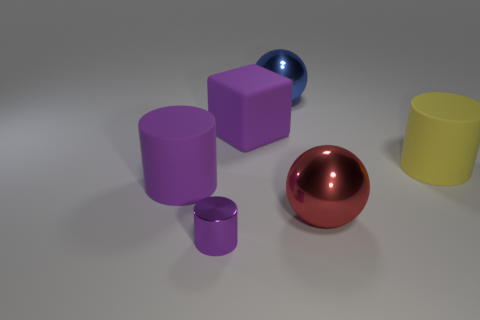Subtract all matte cylinders. How many cylinders are left? 1 Add 3 purple metallic cylinders. How many objects exist? 9 Subtract all balls. How many objects are left? 4 Add 2 tiny cylinders. How many tiny cylinders are left? 3 Add 6 brown rubber cubes. How many brown rubber cubes exist? 6 Subtract 1 yellow cylinders. How many objects are left? 5 Subtract all large yellow balls. Subtract all large blue things. How many objects are left? 5 